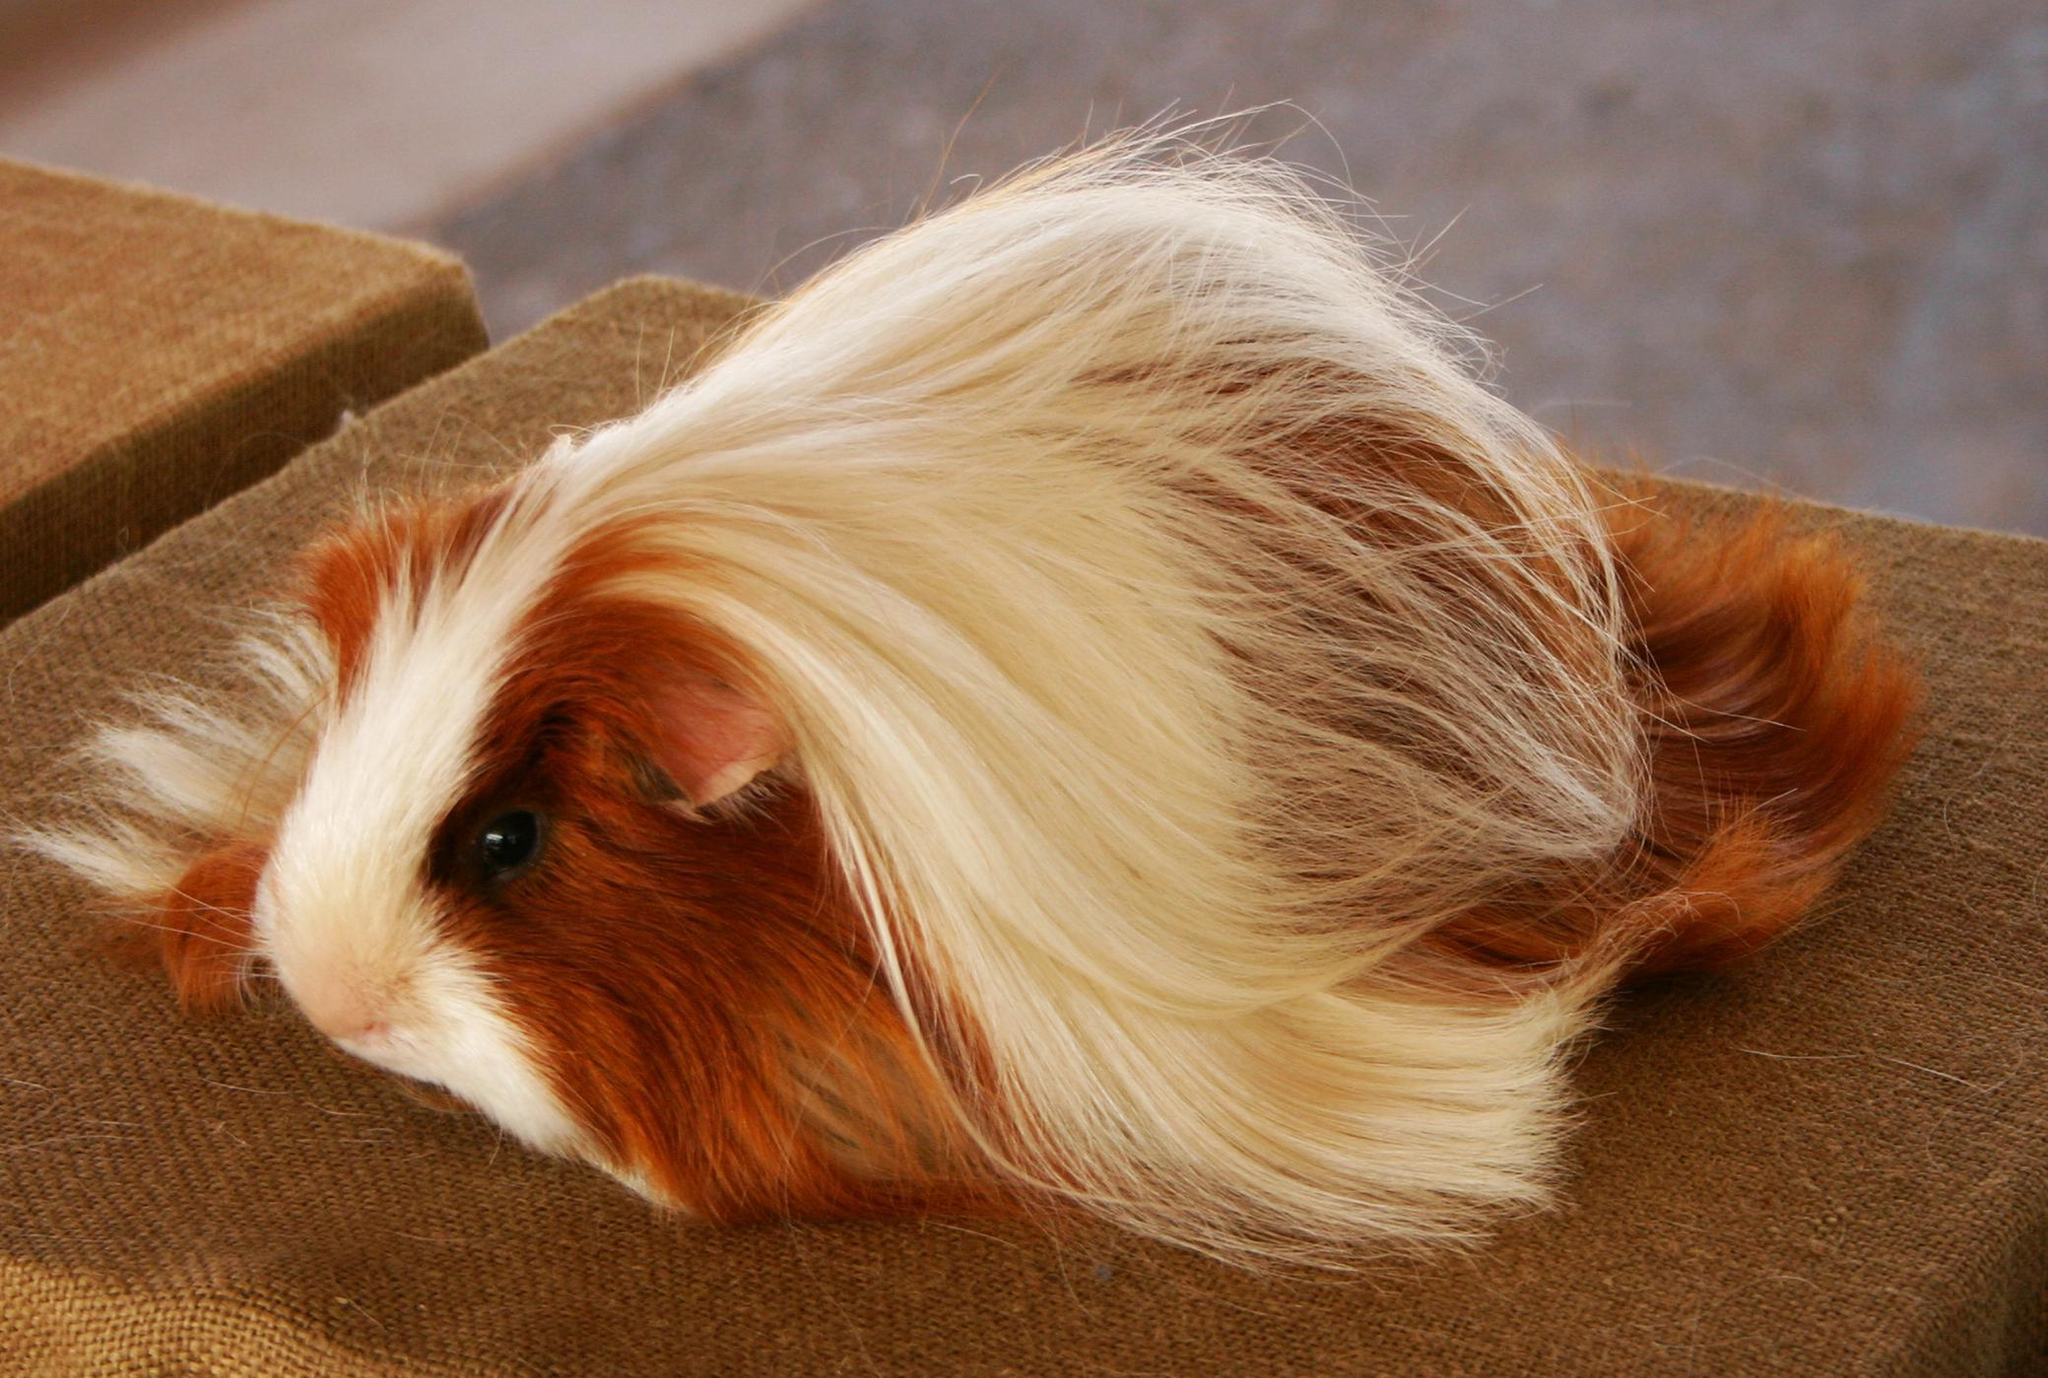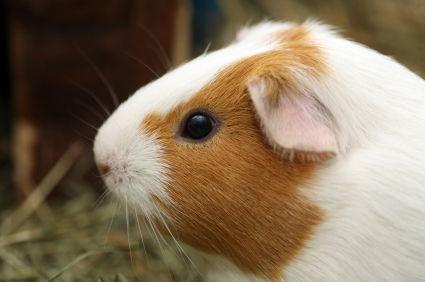The first image is the image on the left, the second image is the image on the right. Assess this claim about the two images: "There are two different guinea pigs featured here.". Correct or not? Answer yes or no. Yes. 